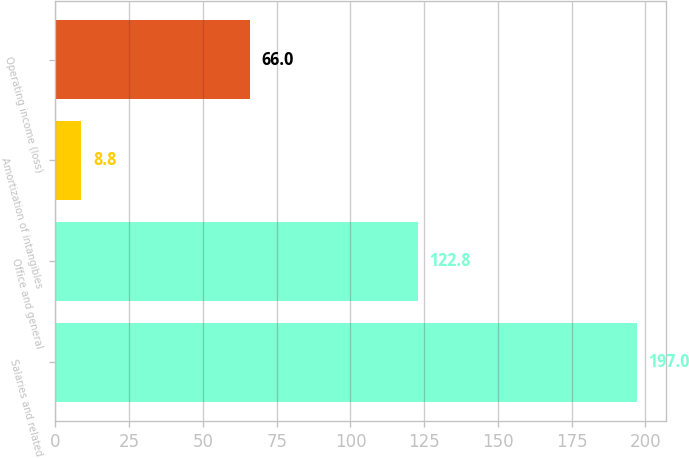Convert chart. <chart><loc_0><loc_0><loc_500><loc_500><bar_chart><fcel>Salaries and related<fcel>Office and general<fcel>Amortization of intangibles<fcel>Operating income (loss)<nl><fcel>197<fcel>122.8<fcel>8.8<fcel>66<nl></chart> 